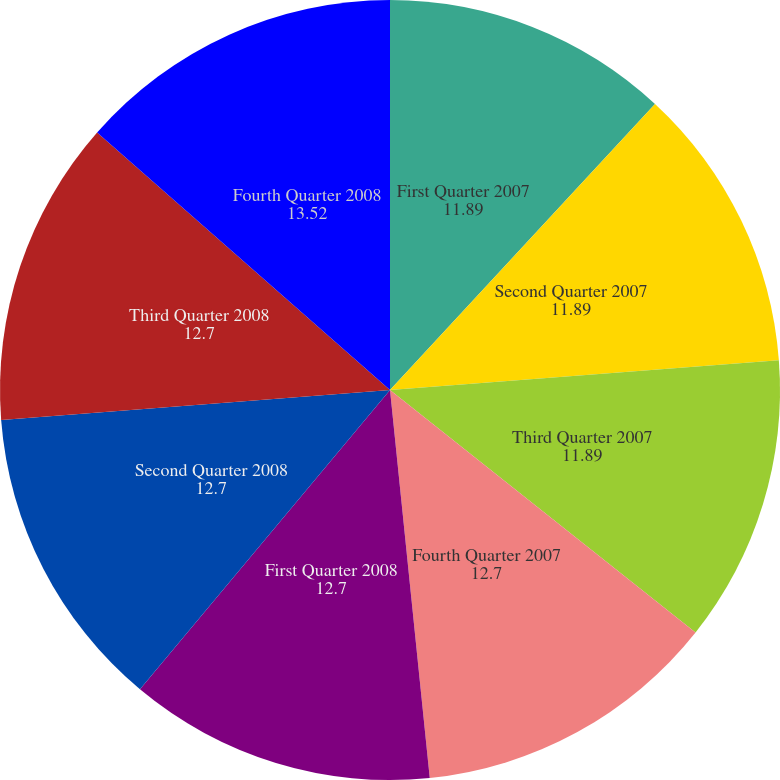Convert chart. <chart><loc_0><loc_0><loc_500><loc_500><pie_chart><fcel>First Quarter 2007<fcel>Second Quarter 2007<fcel>Third Quarter 2007<fcel>Fourth Quarter 2007<fcel>First Quarter 2008<fcel>Second Quarter 2008<fcel>Third Quarter 2008<fcel>Fourth Quarter 2008<nl><fcel>11.89%<fcel>11.89%<fcel>11.89%<fcel>12.7%<fcel>12.7%<fcel>12.7%<fcel>12.7%<fcel>13.52%<nl></chart> 